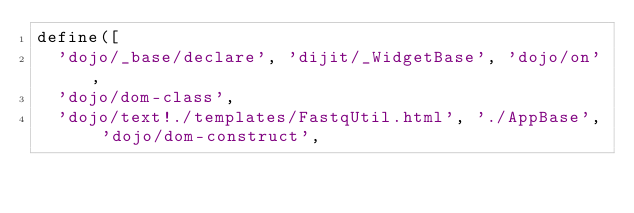Convert code to text. <code><loc_0><loc_0><loc_500><loc_500><_JavaScript_>define([
  'dojo/_base/declare', 'dijit/_WidgetBase', 'dojo/on',
  'dojo/dom-class',
  'dojo/text!./templates/FastqUtil.html', './AppBase', 'dojo/dom-construct',</code> 